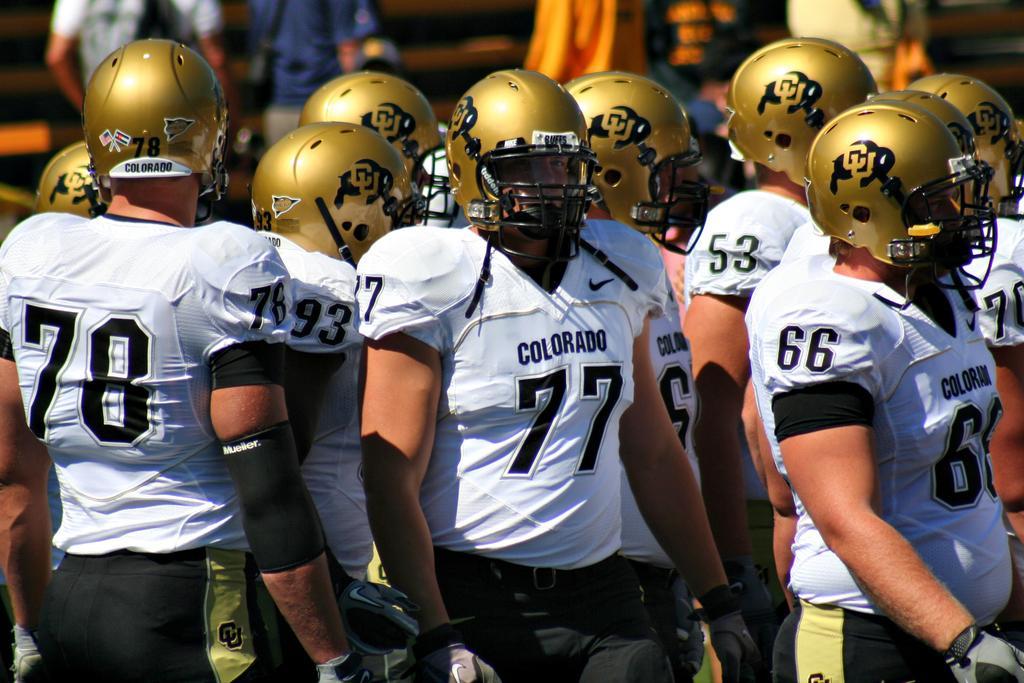Please provide a concise description of this image. In this image I can see group of people are standing and wearing helmets which are gold in color. The background of the image is blurred. 